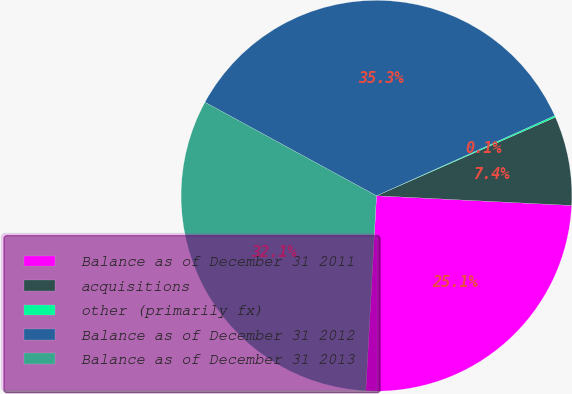Convert chart to OTSL. <chart><loc_0><loc_0><loc_500><loc_500><pie_chart><fcel>Balance as of December 31 2011<fcel>acquisitions<fcel>other (primarily fx)<fcel>Balance as of December 31 2012<fcel>Balance as of December 31 2013<nl><fcel>25.08%<fcel>7.38%<fcel>0.14%<fcel>35.33%<fcel>32.07%<nl></chart> 